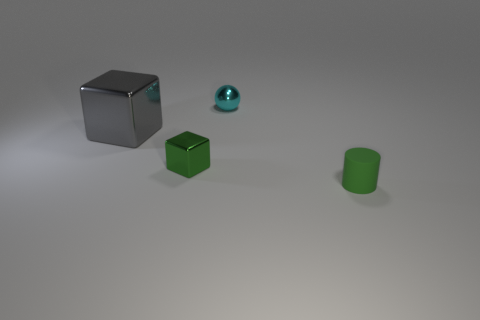What number of objects are both to the right of the gray metal cube and behind the small matte cylinder? To the right of the gray metal cube and behind the small matte cylinder, there is one object, a small green cube. While there appears to be an object, a blue sphere, on the right of the gray cube, it is not behind the small matte cylinder; therefore, it is not counted. 